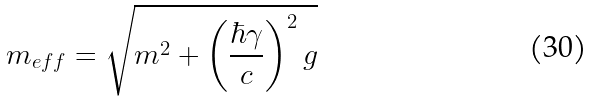Convert formula to latex. <formula><loc_0><loc_0><loc_500><loc_500>m _ { e f f } = \sqrt { m ^ { 2 } + \left ( \frac { \hbar { \gamma } } { c } \right ) ^ { 2 } g }</formula> 